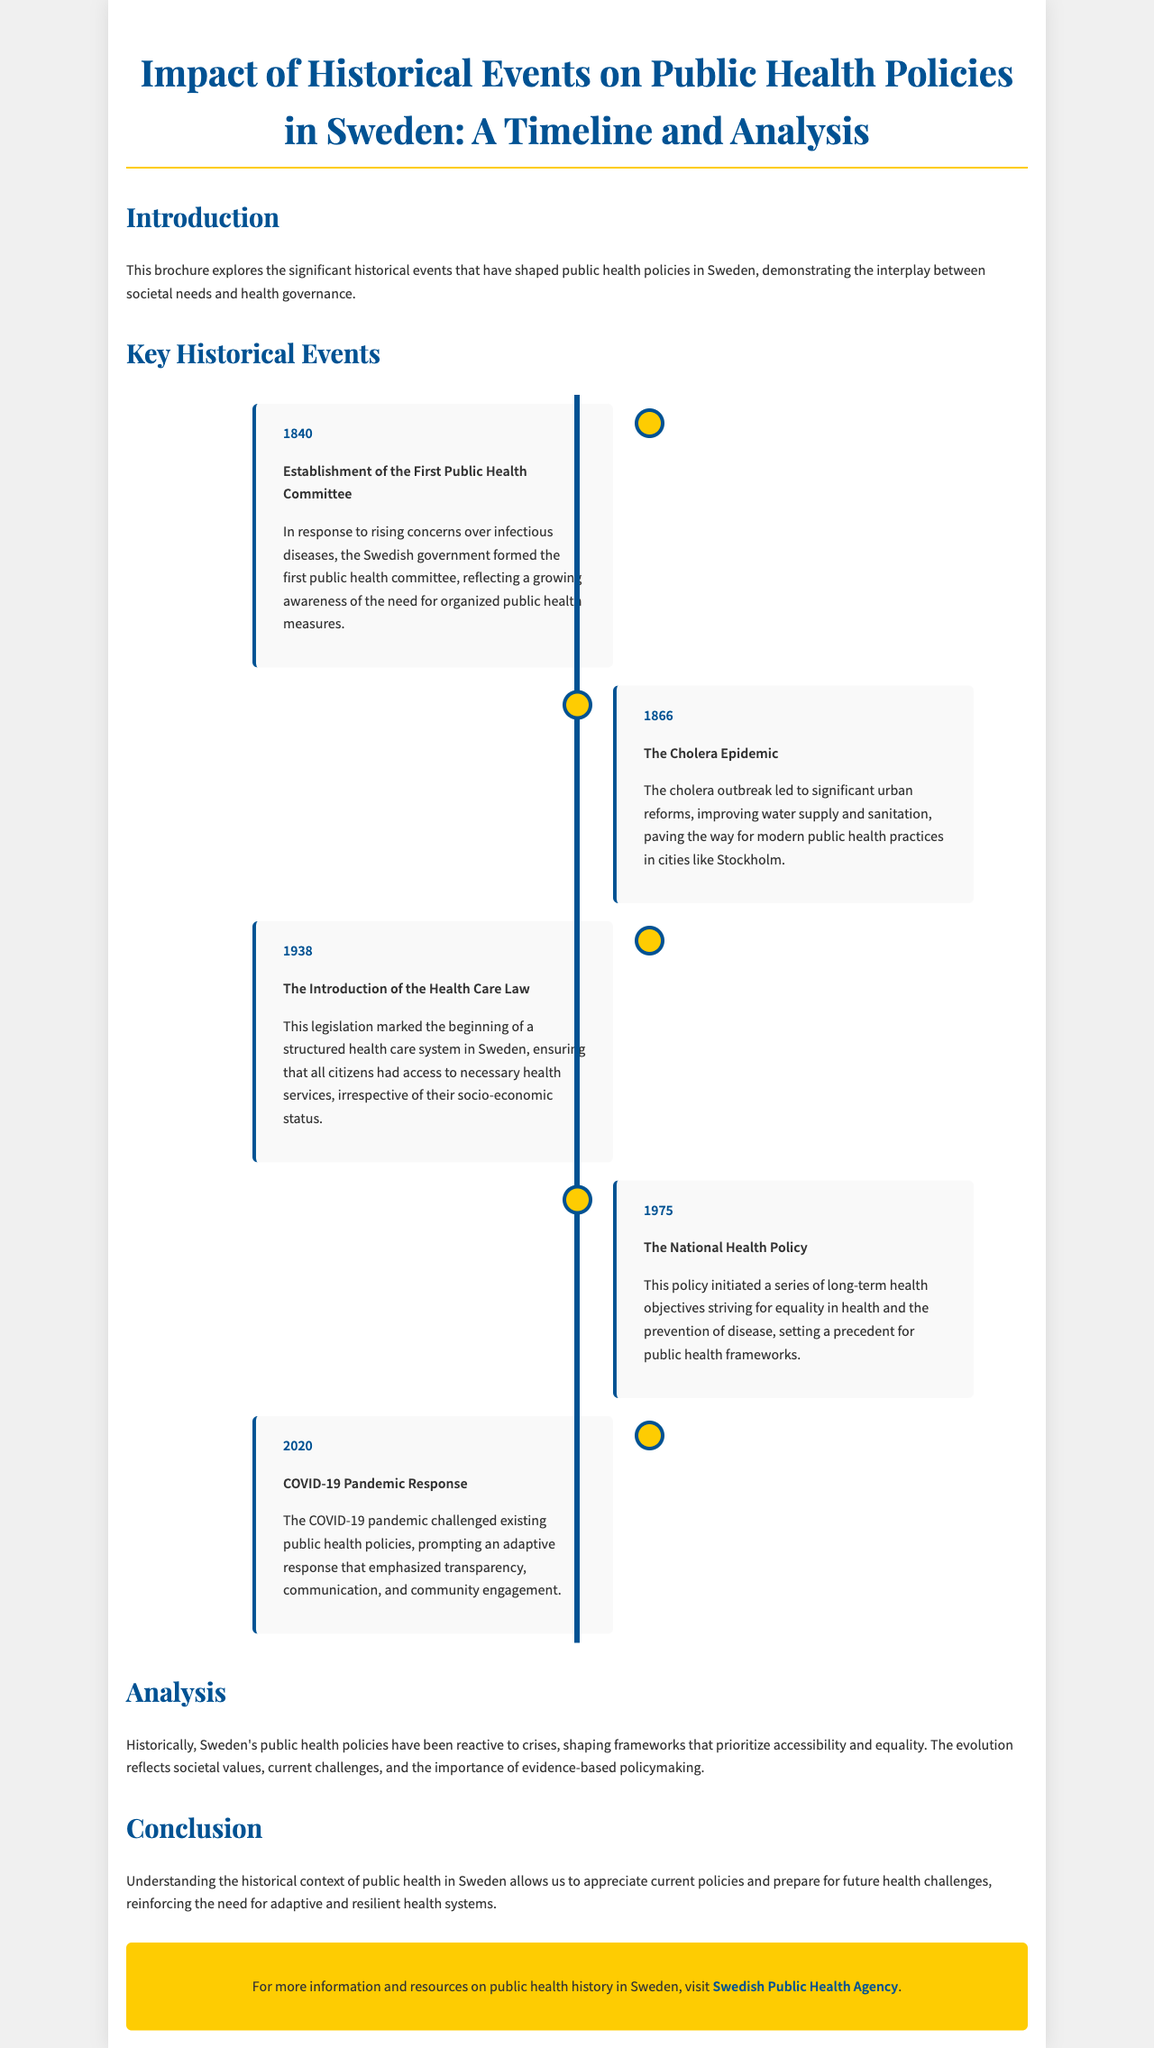what year was the first public health committee established? The document states that the first public health committee was established in response to rising concerns over infectious diseases in the year 1840.
Answer: 1840 what major health crisis occurred in 1866? The document mentions the cholera outbreak as a significant event in the year 1866, which led to urban reforms.
Answer: Cholera Epidemic when was the Health Care Law introduced? According to the timeline in the document, the Health Care Law was introduced in the year 1938.
Answer: 1938 what was initiated by the National Health Policy in 1975? The document explains that the National Health Policy initiated a series of long-term health objectives striving for equality in health.
Answer: Long-term health objectives how did the COVID-19 pandemic affect public health policies? The document indicates that the COVID-19 pandemic prompted an adaptive response emphasizing transparency, communication, and community engagement.
Answer: Adaptive response what has been the historical focus of Sweden's public health policies? The analysis in the document highlights that Sweden's public health policies have historically prioritized accessibility and equality in health.
Answer: Accessibility and equality what is the purpose of the brochure? The introduction states that the purpose of the brochure is to explore significant historical events shaping public health policies in Sweden.
Answer: Explore historical events where can one find more information about public health history in Sweden? The document provides a link to the Swedish Public Health Agency for further resources on public health history.
Answer: Swedish Public Health Agency 